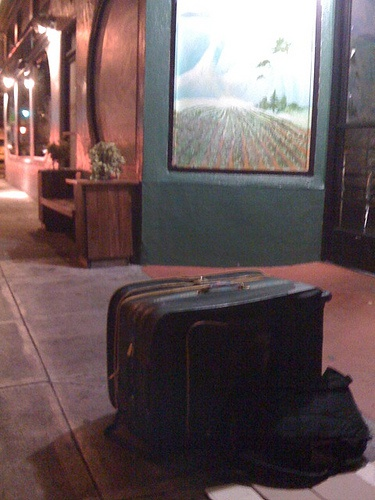Describe the objects in this image and their specific colors. I can see suitcase in tan, black, gray, brown, and maroon tones, handbag in tan, black, and gray tones, bench in tan, maroon, black, and brown tones, and potted plant in tan, gray, brown, and maroon tones in this image. 